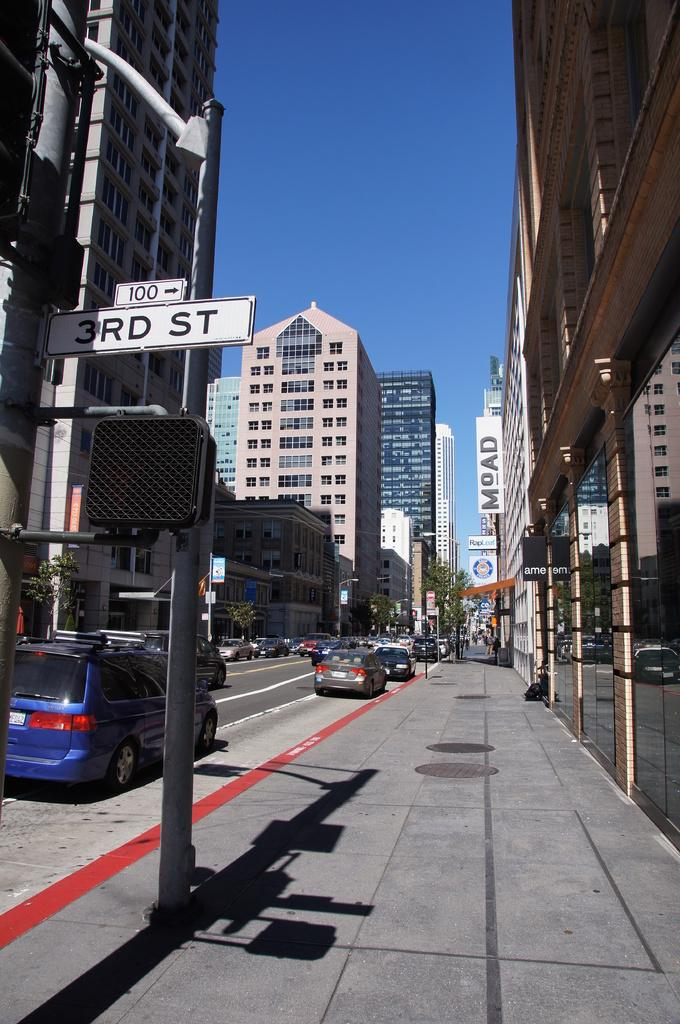What can be seen on the streets in the image? There are vehicles on the road in the image. What structures are present in the image? There are sign boards, poles, buildings, and hoardings in the image. What type of vegetation is visible in the image? There are trees in the image. What type of liquid is flowing on the ground in the image? There is no liquid flowing on the ground in the image. How does the way the vehicles are moving in the image? The way the vehicles are moving cannot be determined from the image alone, as we cannot see the vehicles in motion. 